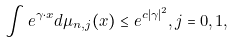Convert formula to latex. <formula><loc_0><loc_0><loc_500><loc_500>\int e ^ { \gamma \cdot x } d \mu _ { n , j } ( x ) \leq e ^ { c | \gamma | ^ { 2 } } , j = 0 , 1 ,</formula> 